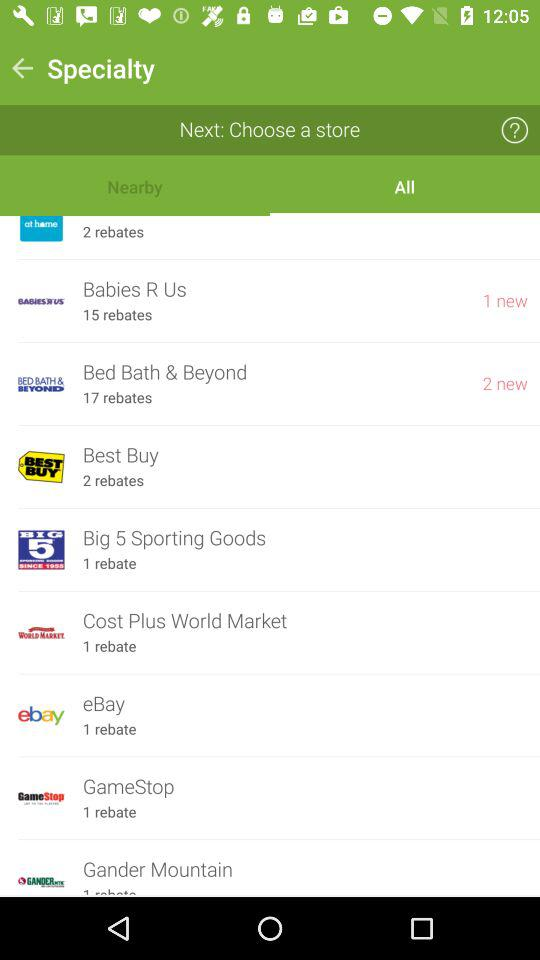Which store has 2 new notifications? The store is "Bed Bath & Beyond". 